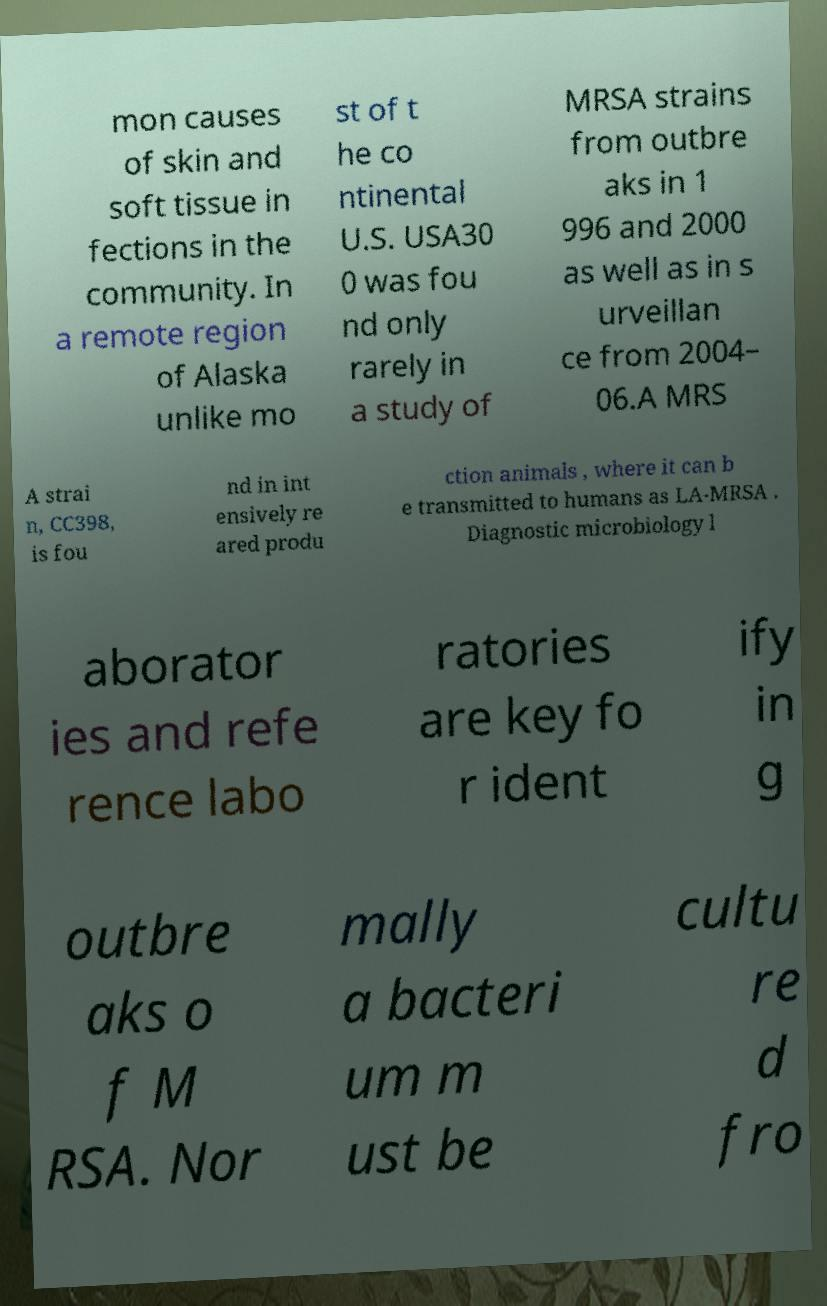Could you assist in decoding the text presented in this image and type it out clearly? mon causes of skin and soft tissue in fections in the community. In a remote region of Alaska unlike mo st of t he co ntinental U.S. USA30 0 was fou nd only rarely in a study of MRSA strains from outbre aks in 1 996 and 2000 as well as in s urveillan ce from 2004– 06.A MRS A strai n, CC398, is fou nd in int ensively re ared produ ction animals , where it can b e transmitted to humans as LA-MRSA . Diagnostic microbiology l aborator ies and refe rence labo ratories are key fo r ident ify in g outbre aks o f M RSA. Nor mally a bacteri um m ust be cultu re d fro 